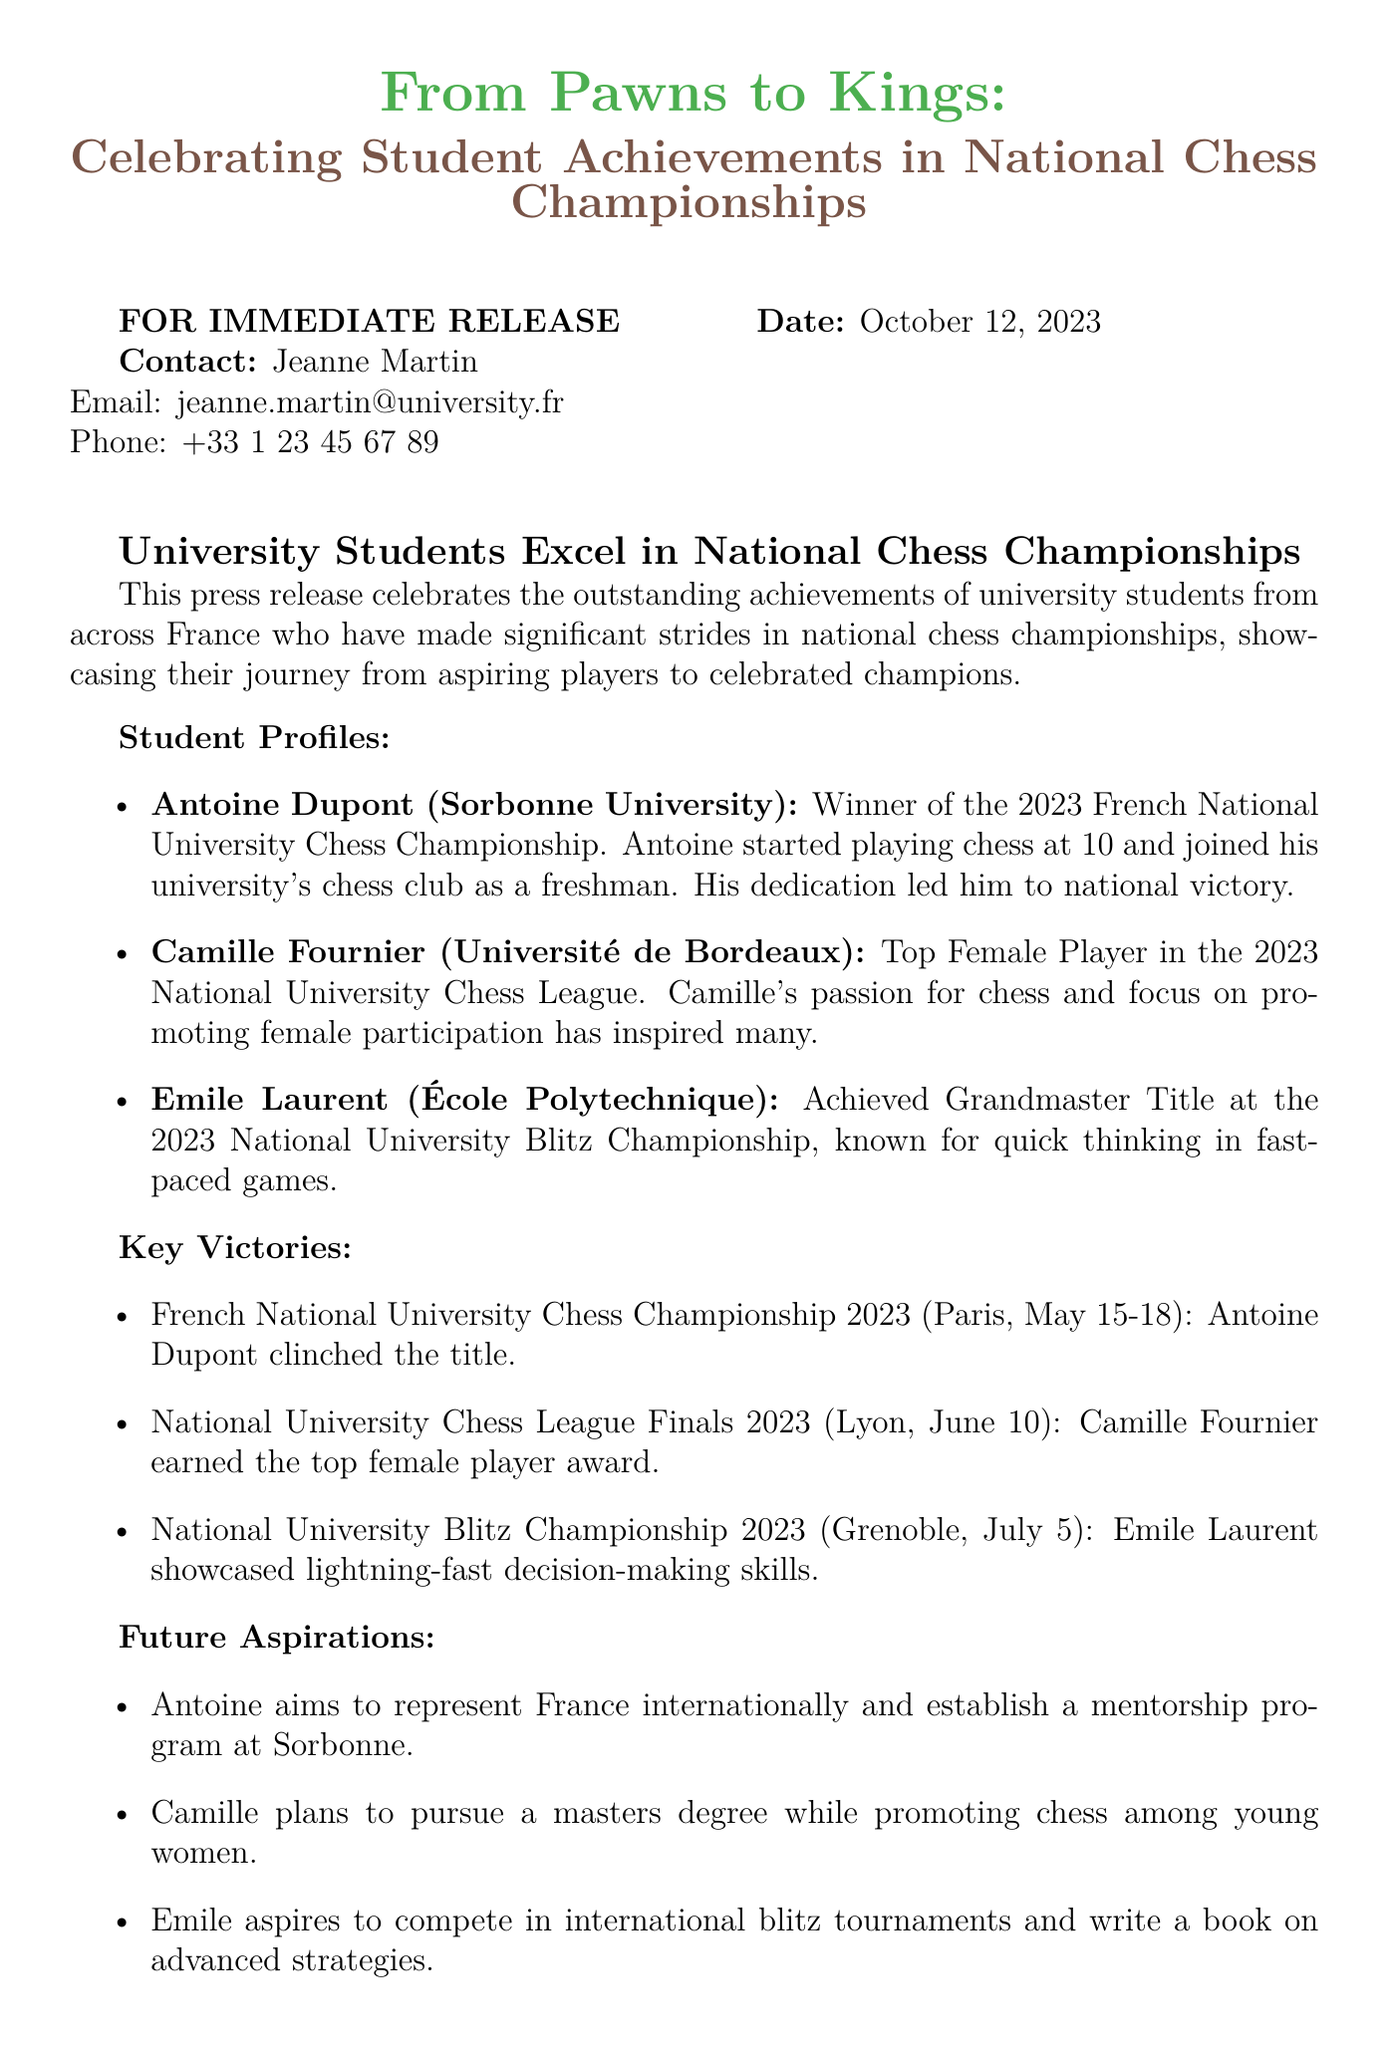what is the title of the press release? The title of the press release is highlighted in large text within the document.
Answer: From Pawns to Kings: Celebrating Student Achievements in National Chess Championships who is the contact person for this press release? The document lists a contact for inquiries at the top of the press release.
Answer: Jeanne Martin when was the press release dated? The date of the press release is stated near the top.
Answer: October 12, 2023 who won the 2023 French National University Chess Championship? The student profile section explicitly names the winner of the championship.
Answer: Antoine Dupont which university does Camille Fournier represent? The document specifies the university associated with each student in the profile section.
Answer: Université de Bordeaux what is Emile Laurent's achievement in 2023? The document highlights Emile's specific accomplishment within the National University Blitz Championship.
Answer: Grandmaster Title what are Antoine's future aspirations? Antoine's goals for the future are listed under the Future Aspirations section.
Answer: Represent France internationally and establish a mentorship program how did Camille contribute to chess as stated in the document? The press release emphasizes Camille's focus on promoting a particular group within chess.
Answer: Promoting female participation where was the National University Blitz Championship held? The location of the championship is mentioned in the Key Victories section.
Answer: Grenoble 